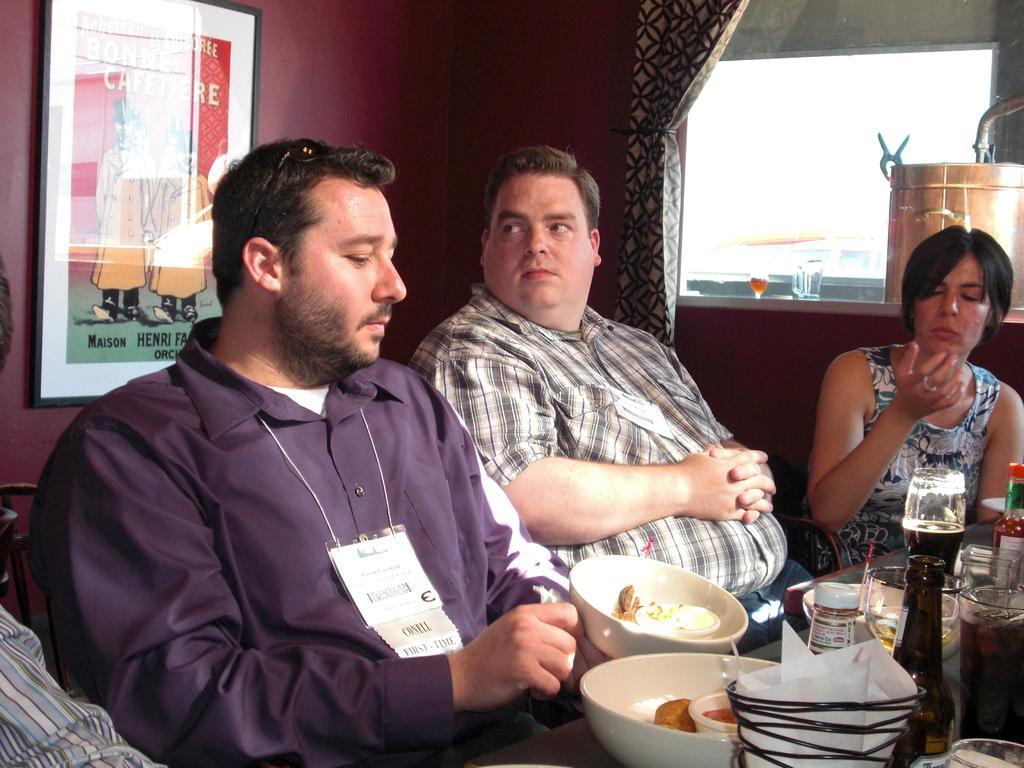How would you summarize this image in a sentence or two? This picture shows three people seated on the chairs and we see some bowls and some food, bottles ,sauces on the table and we see a photo frame on the wall 